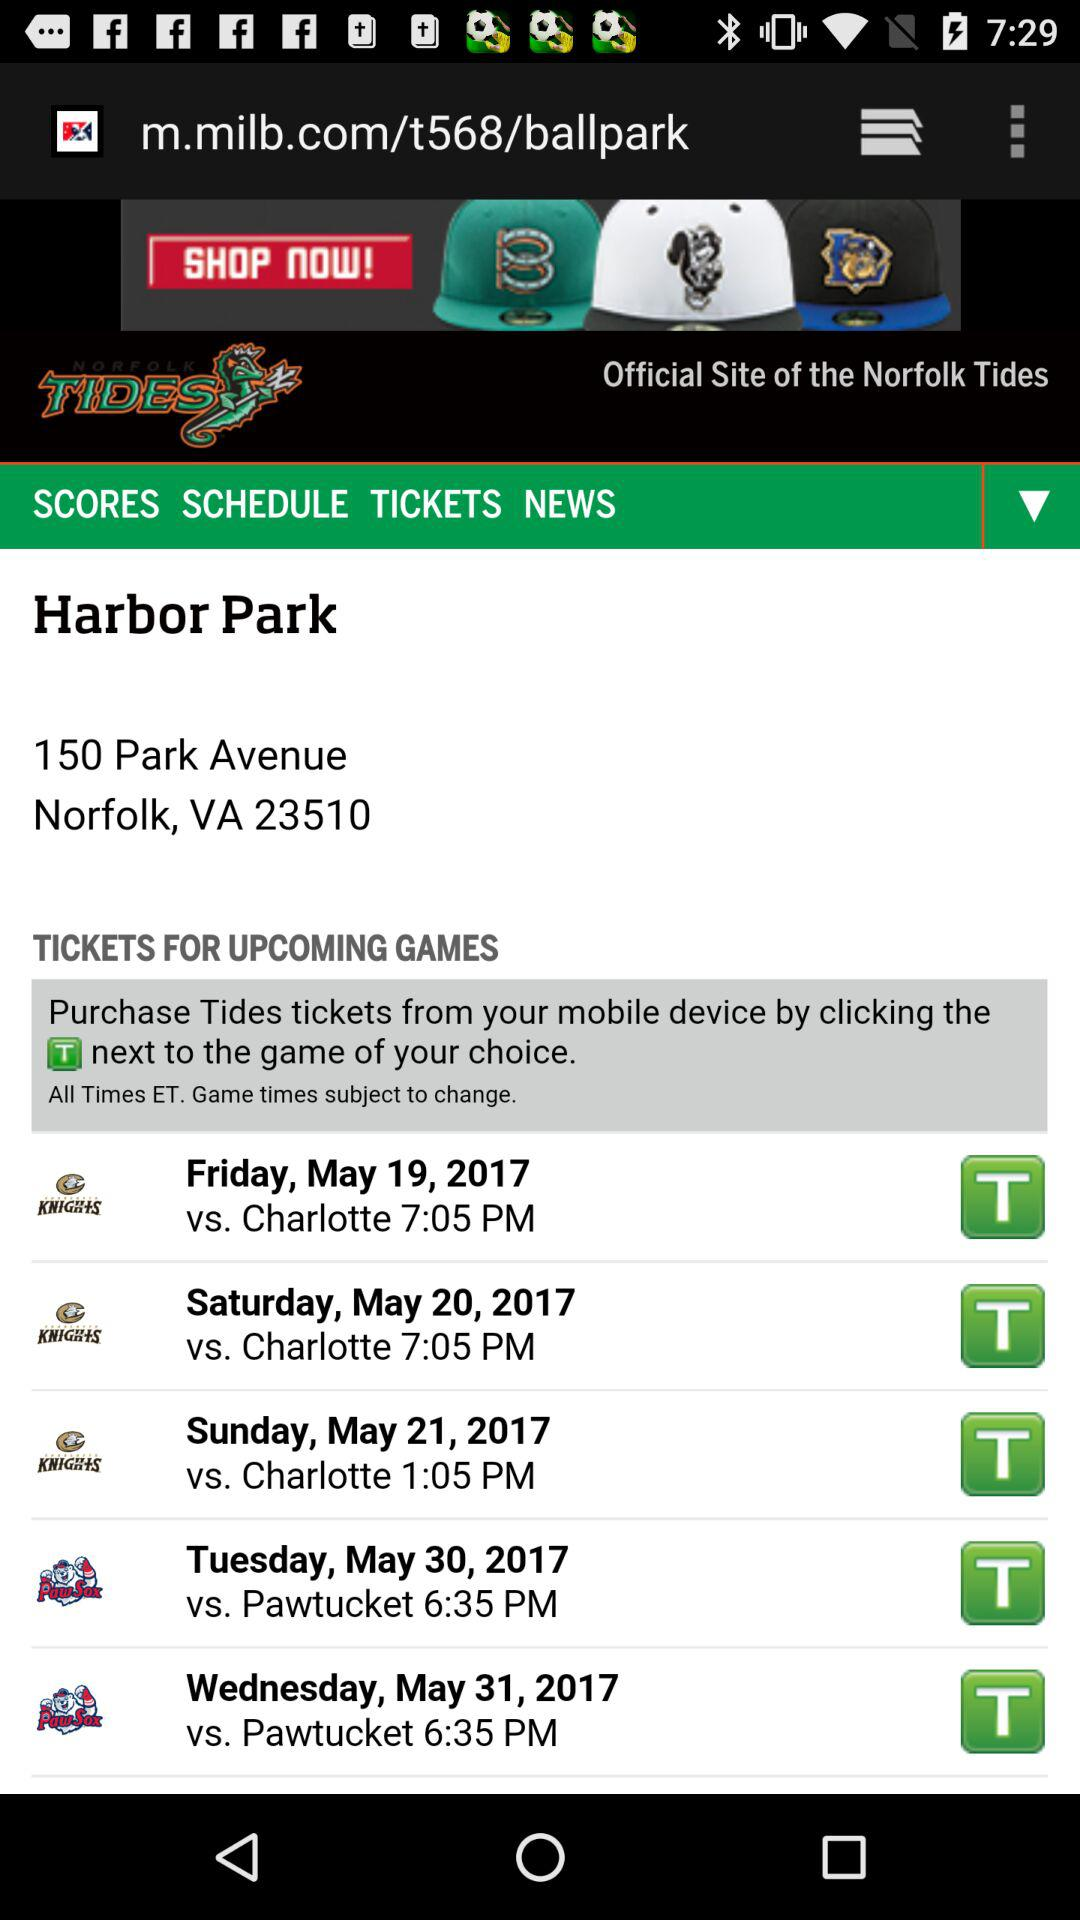What team will play on May 19th? The team is "Charlotte". 